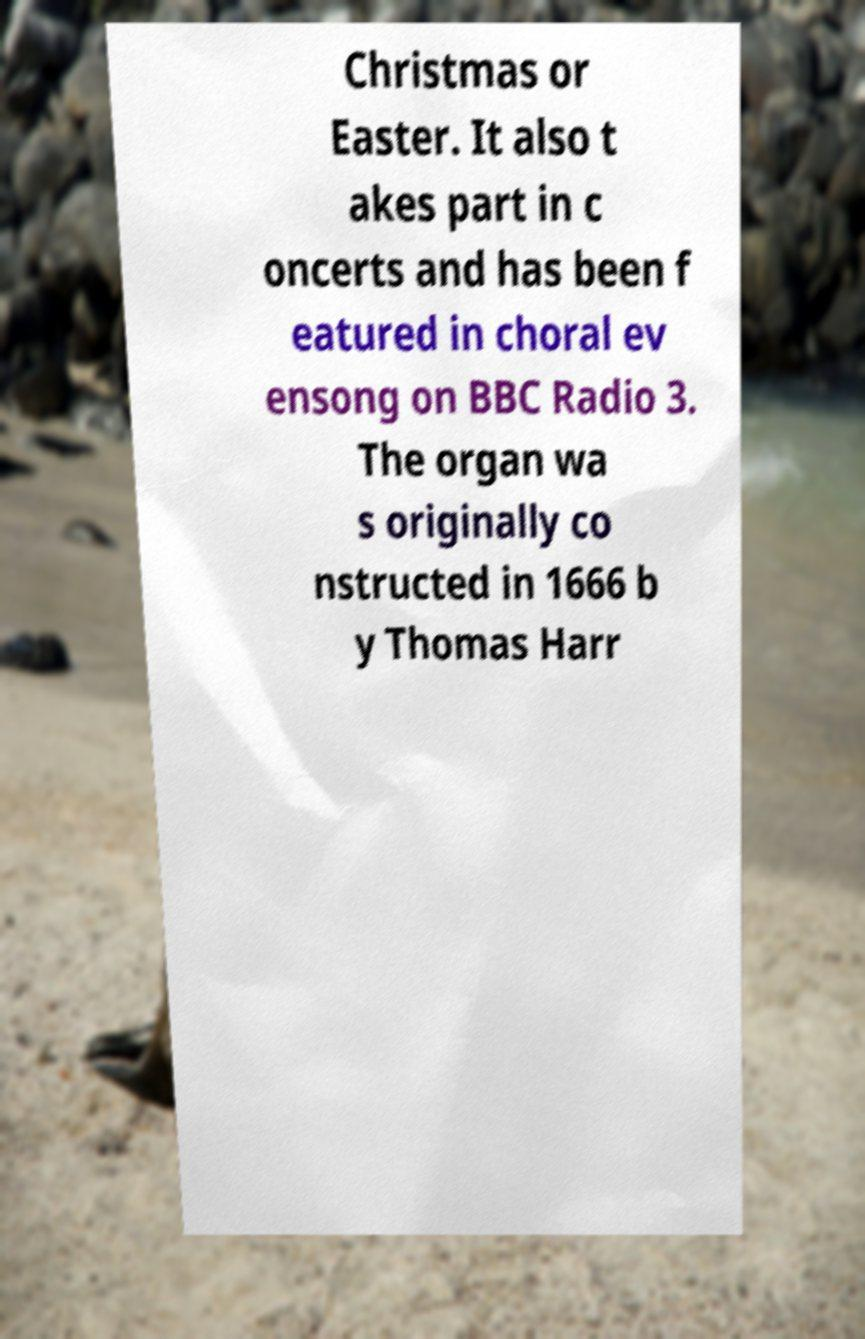I need the written content from this picture converted into text. Can you do that? Christmas or Easter. It also t akes part in c oncerts and has been f eatured in choral ev ensong on BBC Radio 3. The organ wa s originally co nstructed in 1666 b y Thomas Harr 